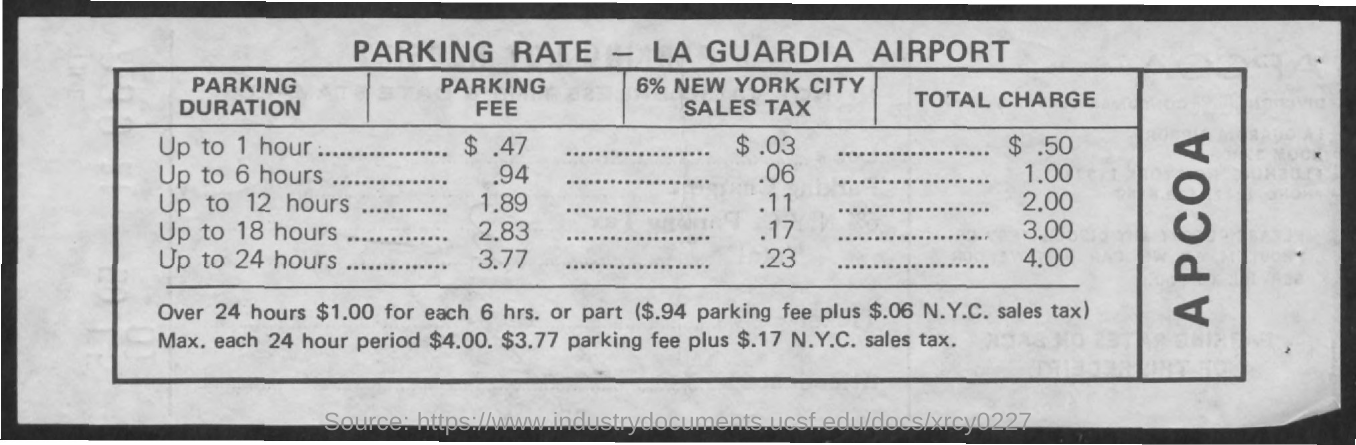What is the name of the airport
Offer a very short reply. La guardia airport. How much is the parking fee upto 1 hour
Ensure brevity in your answer.  $ .47. What is the total charge for parking upo 1 hour
Ensure brevity in your answer.  $ .50. How much is the parking fee upto 24 hours
Give a very brief answer. $ 3.77. How much is the 6% new york city sales tax for parking upto 12 hours
Give a very brief answer. $ .11. What is the total charge for parking upto 24 hours
Offer a terse response. $ 4.00. How much is the parking fee for upto 18 hours
Ensure brevity in your answer.  $2.83. How much is the parking fee for upto 6 hours
Keep it short and to the point. .94. 